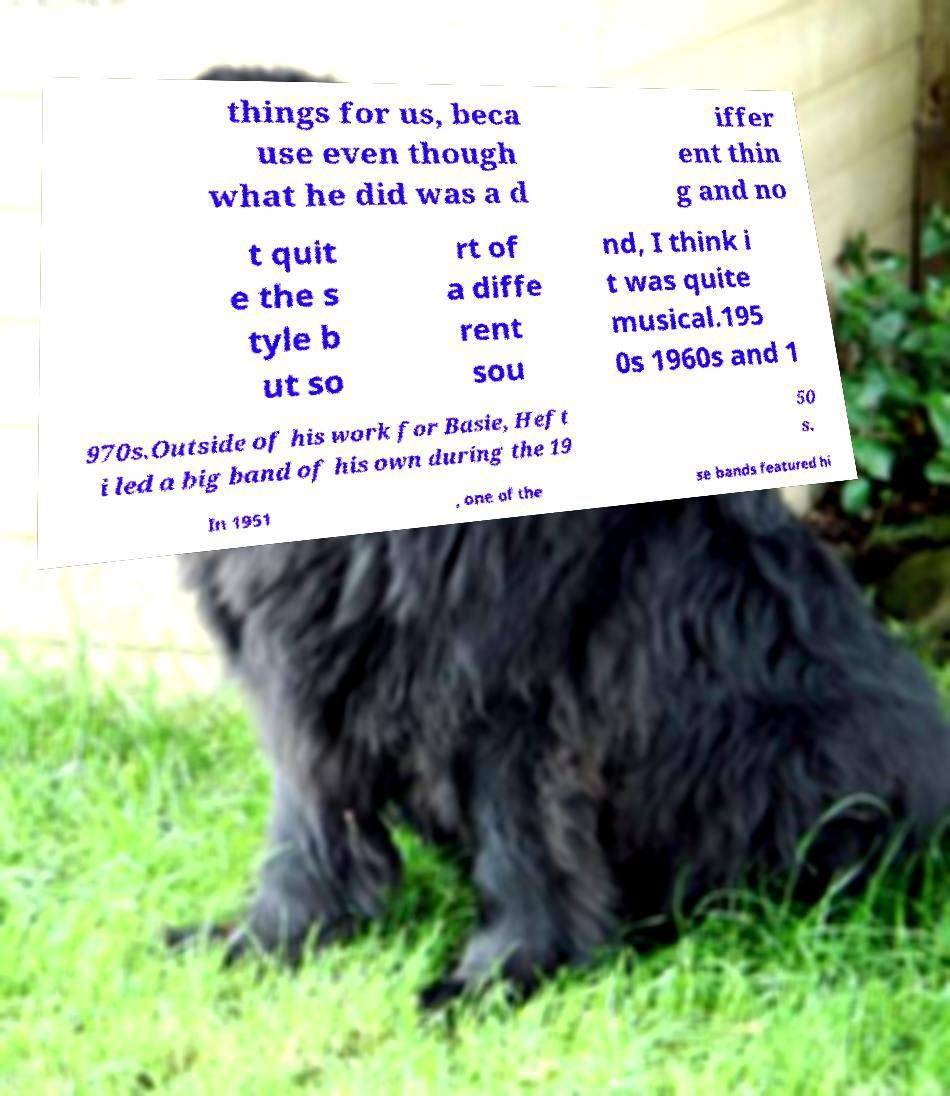For documentation purposes, I need the text within this image transcribed. Could you provide that? things for us, beca use even though what he did was a d iffer ent thin g and no t quit e the s tyle b ut so rt of a diffe rent sou nd, I think i t was quite musical.195 0s 1960s and 1 970s.Outside of his work for Basie, Heft i led a big band of his own during the 19 50 s. In 1951 , one of the se bands featured hi 